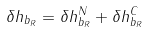<formula> <loc_0><loc_0><loc_500><loc_500>\delta h _ { b _ { R } } = \delta h _ { b _ { R } } ^ { N } + \delta h _ { b _ { R } } ^ { C }</formula> 